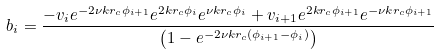Convert formula to latex. <formula><loc_0><loc_0><loc_500><loc_500>b _ { i } = \frac { - v _ { i } e ^ { - 2 \nu k r _ { c } \phi _ { i + 1 } } e ^ { 2 k r _ { c } \phi _ { i } } e ^ { \nu k r _ { c } \phi _ { i } } + v _ { i + 1 } e ^ { 2 k r _ { c } \phi _ { i + 1 } } e ^ { - \nu k r _ { c } \phi _ { i + 1 } } } { \left ( 1 - e ^ { - 2 \nu k r _ { c } ( \phi _ { i + 1 } - \phi _ { i } ) } \right ) }</formula> 